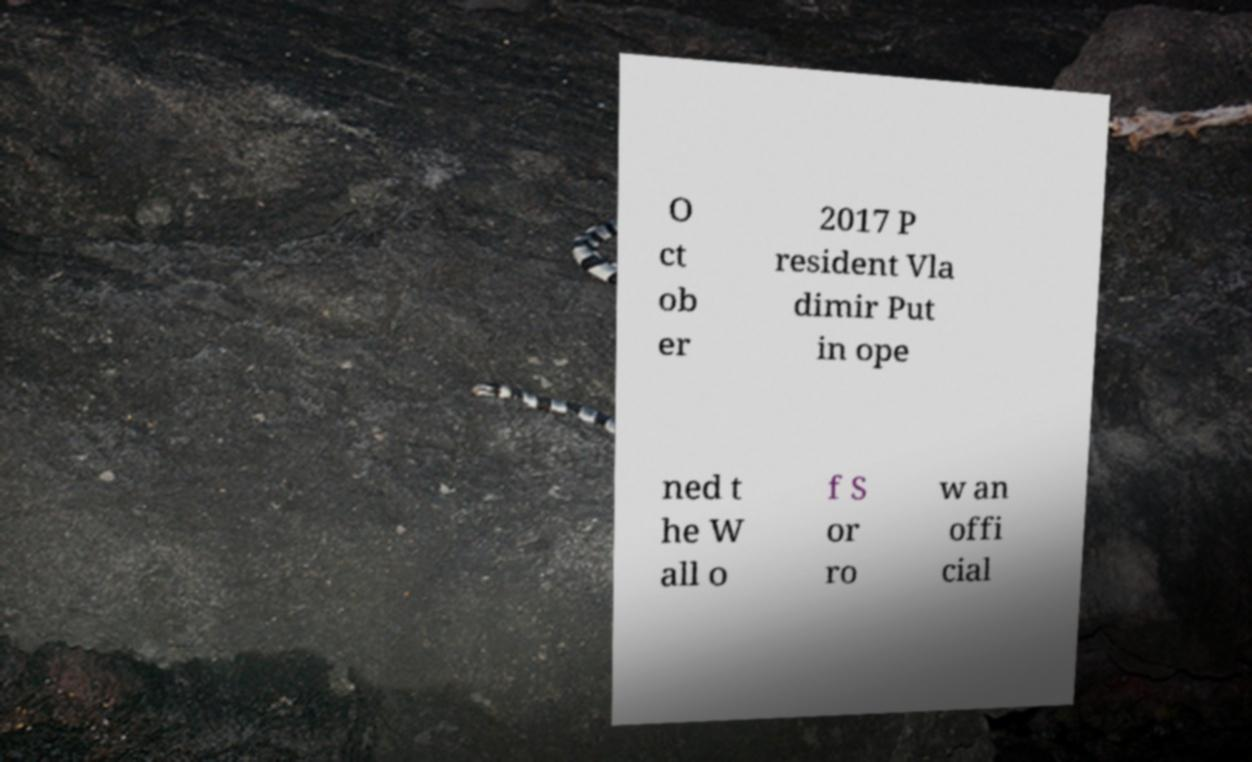For documentation purposes, I need the text within this image transcribed. Could you provide that? O ct ob er 2017 P resident Vla dimir Put in ope ned t he W all o f S or ro w an offi cial 